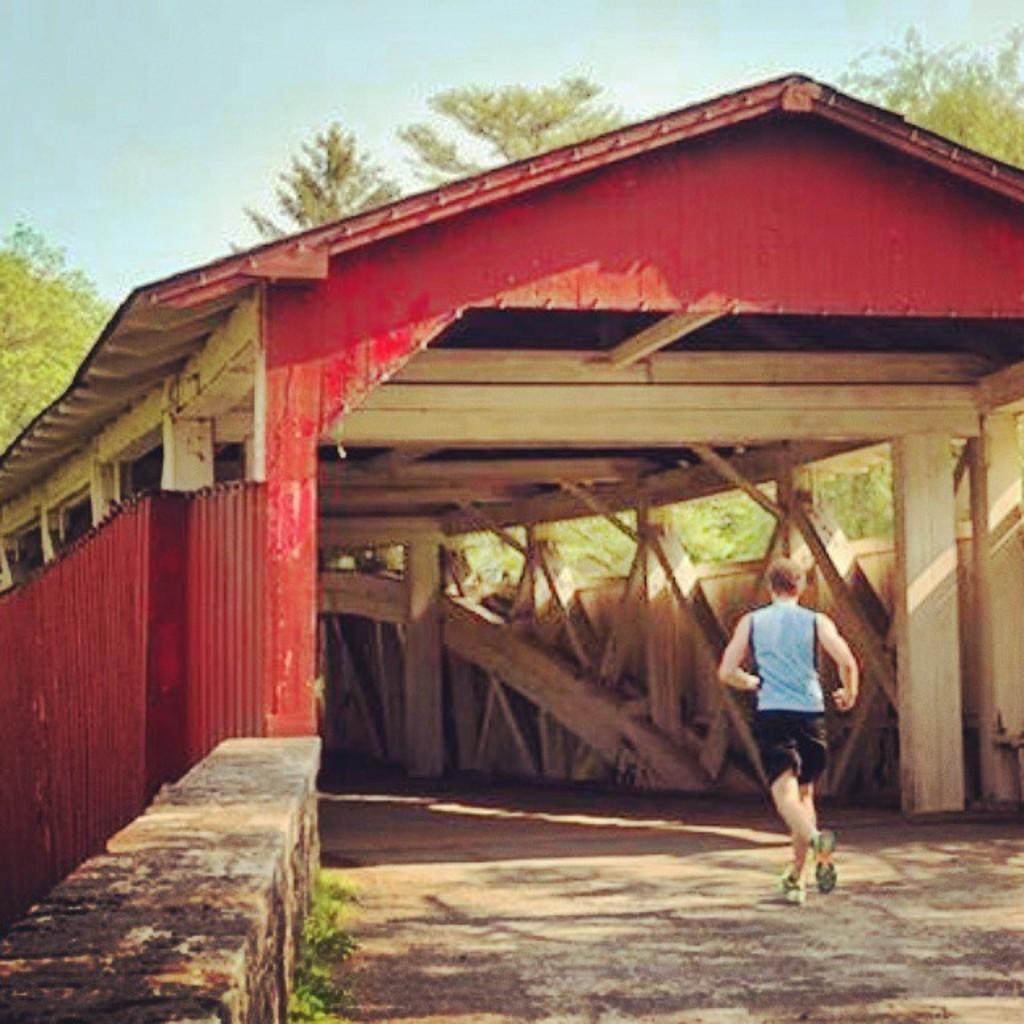Could you give a brief overview of what you see in this image? In the foreground of this image, there is a man on the right running on the path. In the middle, it seems like a shed. In the background, there are trees and the sky. 